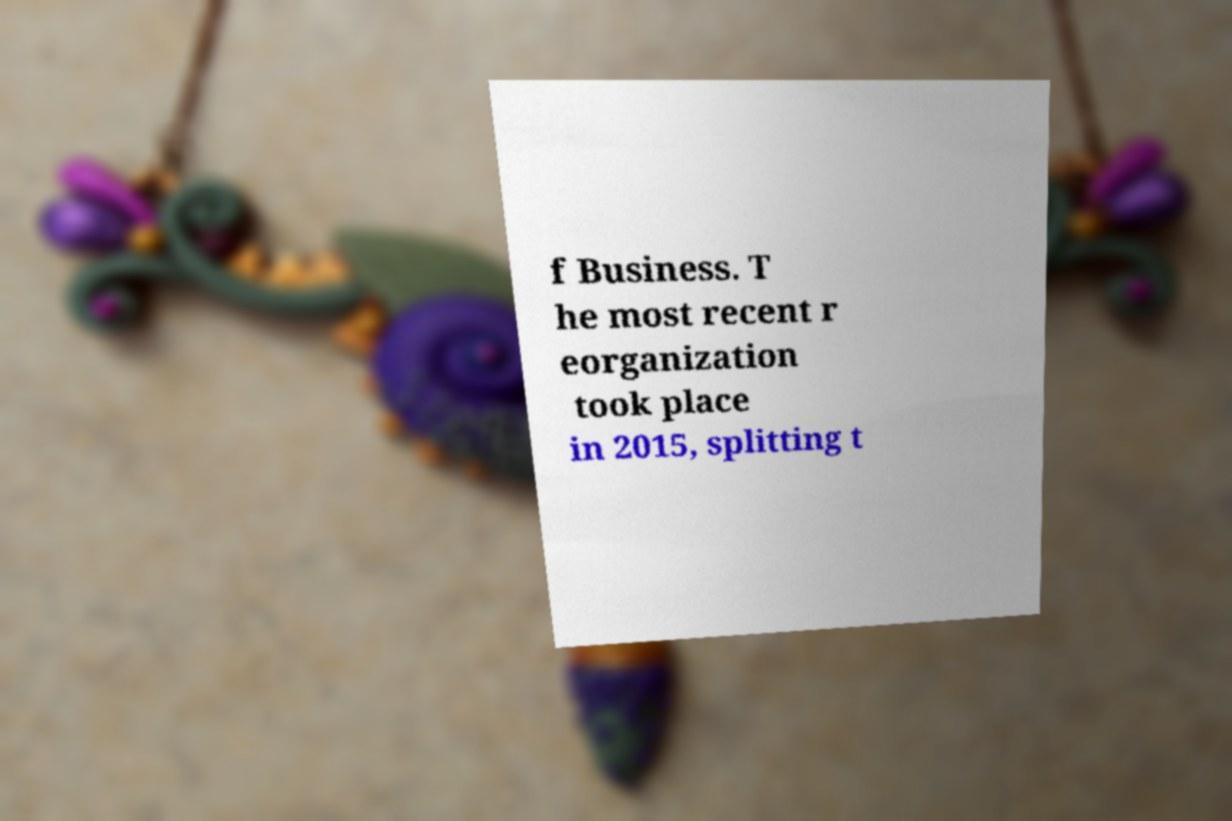For documentation purposes, I need the text within this image transcribed. Could you provide that? f Business. T he most recent r eorganization took place in 2015, splitting t 